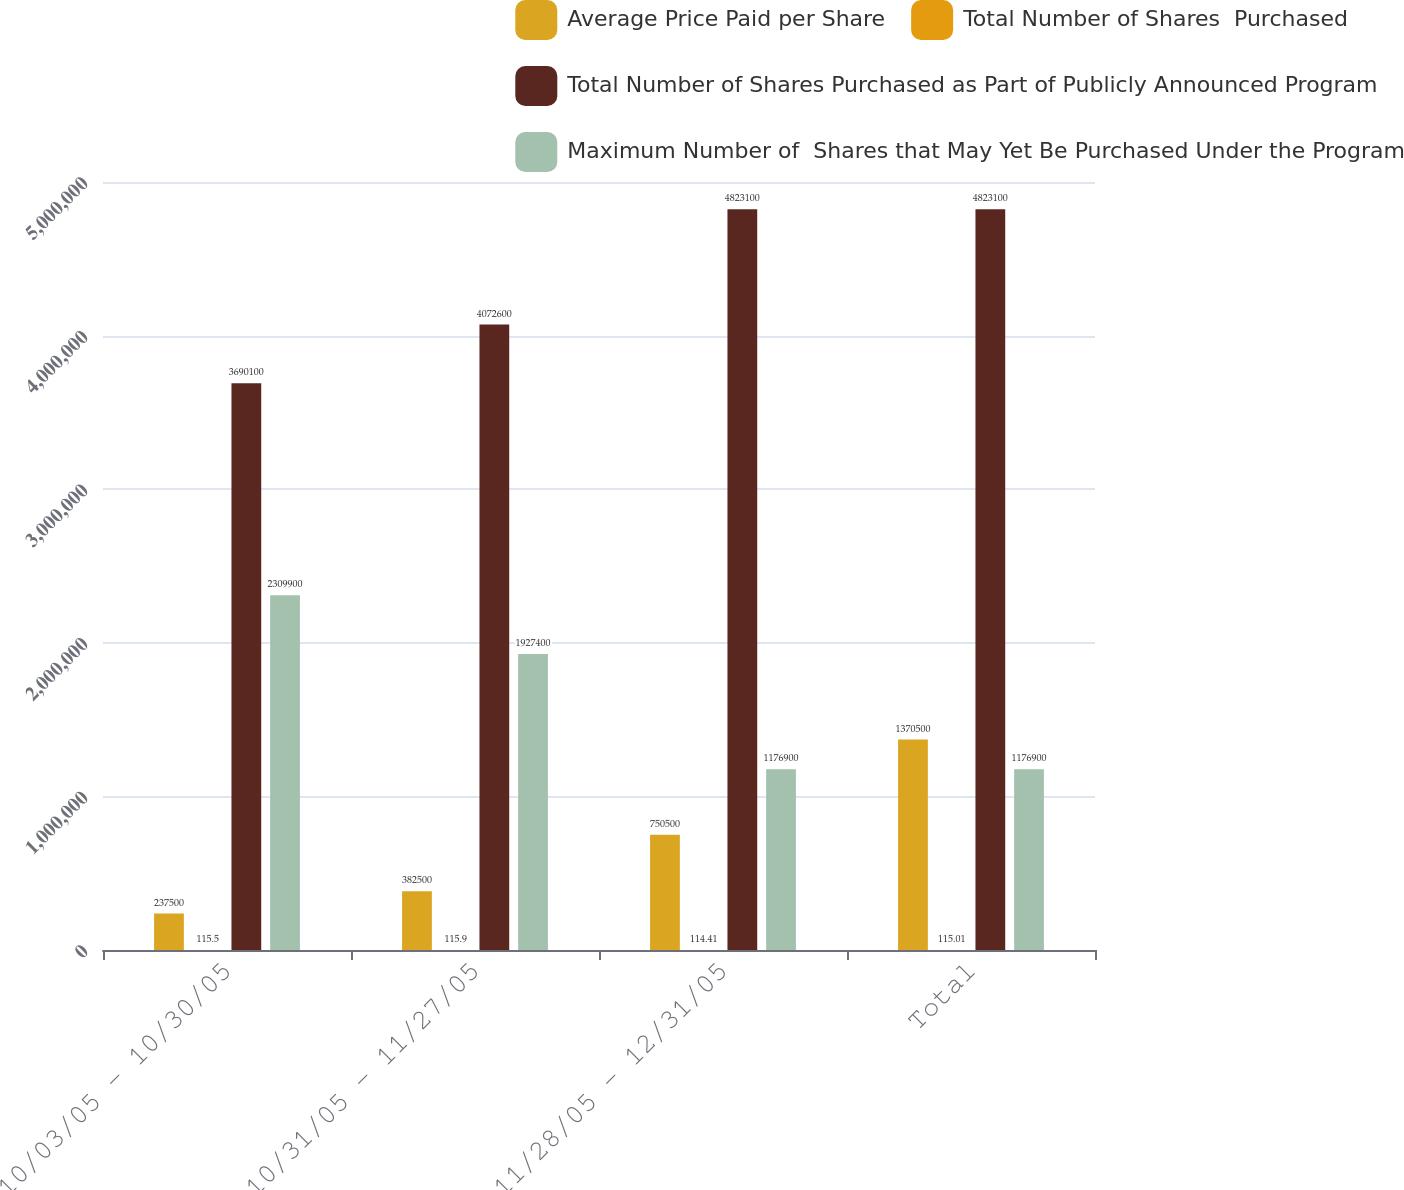<chart> <loc_0><loc_0><loc_500><loc_500><stacked_bar_chart><ecel><fcel>10/03/05 - 10/30/05<fcel>10/31/05 - 11/27/05<fcel>11/28/05 - 12/31/05<fcel>Total<nl><fcel>Average Price Paid per Share<fcel>237500<fcel>382500<fcel>750500<fcel>1.3705e+06<nl><fcel>Total Number of Shares  Purchased<fcel>115.5<fcel>115.9<fcel>114.41<fcel>115.01<nl><fcel>Total Number of Shares Purchased as Part of Publicly Announced Program<fcel>3.6901e+06<fcel>4.0726e+06<fcel>4.8231e+06<fcel>4.8231e+06<nl><fcel>Maximum Number of  Shares that May Yet Be Purchased Under the Program<fcel>2.3099e+06<fcel>1.9274e+06<fcel>1.1769e+06<fcel>1.1769e+06<nl></chart> 